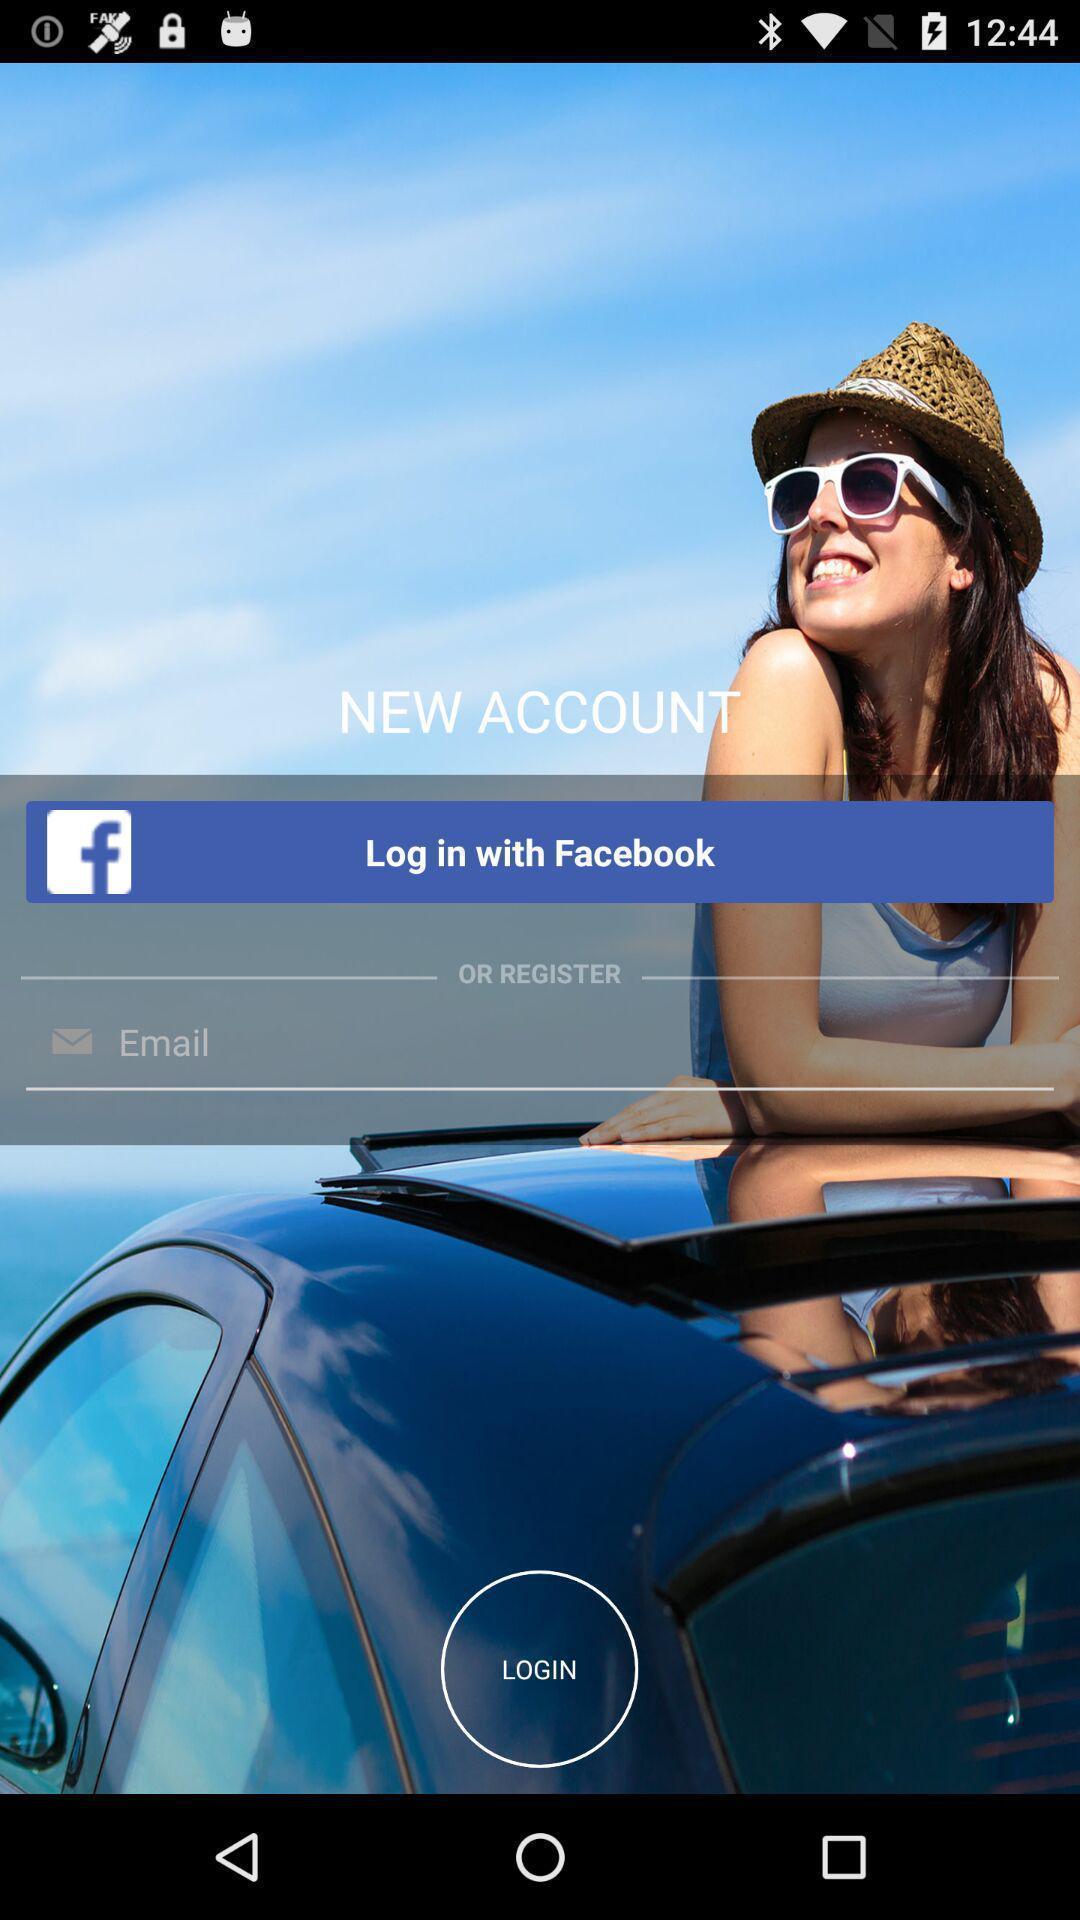Describe the visual elements of this screenshot. Screen displaying the login page. 